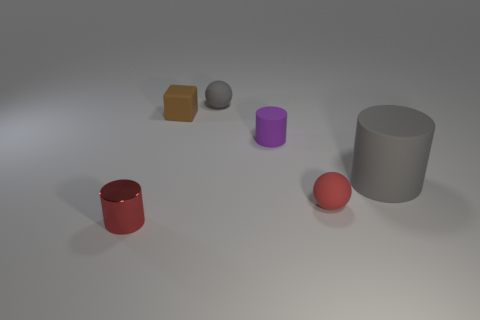Subtract 1 cylinders. How many cylinders are left? 2 Add 4 tiny metallic objects. How many objects exist? 10 Subtract all spheres. How many objects are left? 4 Subtract all tiny purple objects. Subtract all rubber objects. How many objects are left? 0 Add 4 small purple rubber cylinders. How many small purple rubber cylinders are left? 5 Add 2 small brown cylinders. How many small brown cylinders exist? 2 Subtract 0 cyan cylinders. How many objects are left? 6 